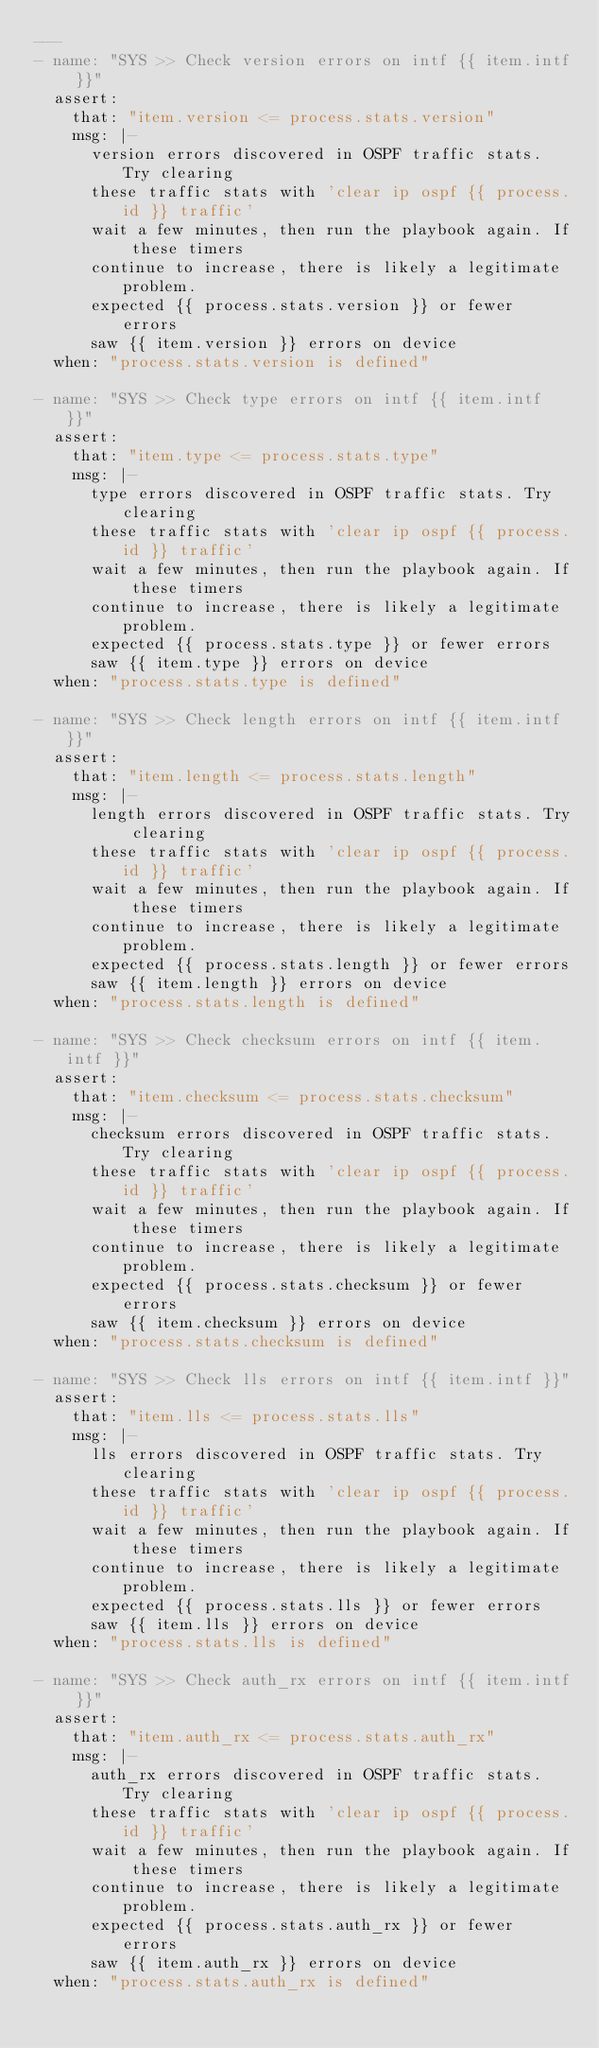Convert code to text. <code><loc_0><loc_0><loc_500><loc_500><_YAML_>---
- name: "SYS >> Check version errors on intf {{ item.intf }}"
  assert:
    that: "item.version <= process.stats.version"
    msg: |-
      version errors discovered in OSPF traffic stats. Try clearing
      these traffic stats with 'clear ip ospf {{ process.id }} traffic'
      wait a few minutes, then run the playbook again. If these timers
      continue to increase, there is likely a legitimate problem.
      expected {{ process.stats.version }} or fewer errors
      saw {{ item.version }} errors on device
  when: "process.stats.version is defined"

- name: "SYS >> Check type errors on intf {{ item.intf }}"
  assert:
    that: "item.type <= process.stats.type"
    msg: |-
      type errors discovered in OSPF traffic stats. Try clearing
      these traffic stats with 'clear ip ospf {{ process.id }} traffic'
      wait a few minutes, then run the playbook again. If these timers
      continue to increase, there is likely a legitimate problem.
      expected {{ process.stats.type }} or fewer errors
      saw {{ item.type }} errors on device
  when: "process.stats.type is defined"

- name: "SYS >> Check length errors on intf {{ item.intf }}"
  assert:
    that: "item.length <= process.stats.length"
    msg: |-
      length errors discovered in OSPF traffic stats. Try clearing
      these traffic stats with 'clear ip ospf {{ process.id }} traffic'
      wait a few minutes, then run the playbook again. If these timers
      continue to increase, there is likely a legitimate problem.
      expected {{ process.stats.length }} or fewer errors
      saw {{ item.length }} errors on device
  when: "process.stats.length is defined"

- name: "SYS >> Check checksum errors on intf {{ item.intf }}"
  assert:
    that: "item.checksum <= process.stats.checksum"
    msg: |-
      checksum errors discovered in OSPF traffic stats. Try clearing
      these traffic stats with 'clear ip ospf {{ process.id }} traffic'
      wait a few minutes, then run the playbook again. If these timers
      continue to increase, there is likely a legitimate problem.
      expected {{ process.stats.checksum }} or fewer errors
      saw {{ item.checksum }} errors on device
  when: "process.stats.checksum is defined"

- name: "SYS >> Check lls errors on intf {{ item.intf }}"
  assert:
    that: "item.lls <= process.stats.lls"
    msg: |-
      lls errors discovered in OSPF traffic stats. Try clearing
      these traffic stats with 'clear ip ospf {{ process.id }} traffic'
      wait a few minutes, then run the playbook again. If these timers
      continue to increase, there is likely a legitimate problem.
      expected {{ process.stats.lls }} or fewer errors
      saw {{ item.lls }} errors on device
  when: "process.stats.lls is defined"

- name: "SYS >> Check auth_rx errors on intf {{ item.intf }}"
  assert:
    that: "item.auth_rx <= process.stats.auth_rx"
    msg: |-
      auth_rx errors discovered in OSPF traffic stats. Try clearing
      these traffic stats with 'clear ip ospf {{ process.id }} traffic'
      wait a few minutes, then run the playbook again. If these timers
      continue to increase, there is likely a legitimate problem.
      expected {{ process.stats.auth_rx }} or fewer errors
      saw {{ item.auth_rx }} errors on device
  when: "process.stats.auth_rx is defined"
</code> 